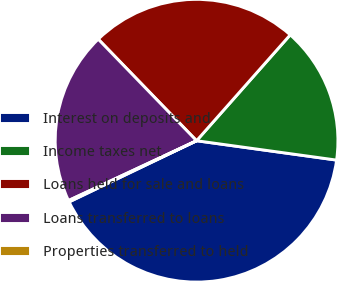<chart> <loc_0><loc_0><loc_500><loc_500><pie_chart><fcel>Interest on deposits and<fcel>Income taxes net<fcel>Loans held for sale and loans<fcel>Loans transferred to loans<fcel>Properties transferred to held<nl><fcel>40.69%<fcel>15.66%<fcel>23.77%<fcel>19.71%<fcel>0.17%<nl></chart> 